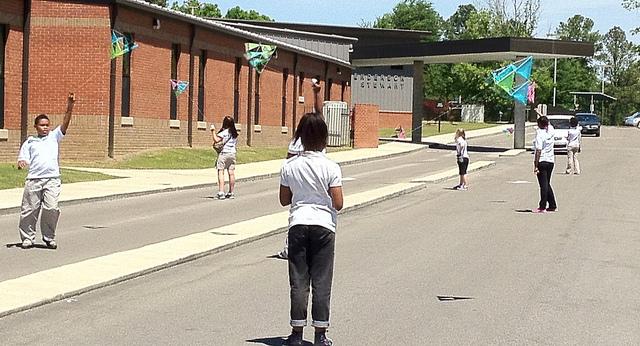What is in the picture?
Write a very short answer. Kids. Does this look like a school building?
Quick response, please. Yes. What type of scene is pictured?
Keep it brief. School. 